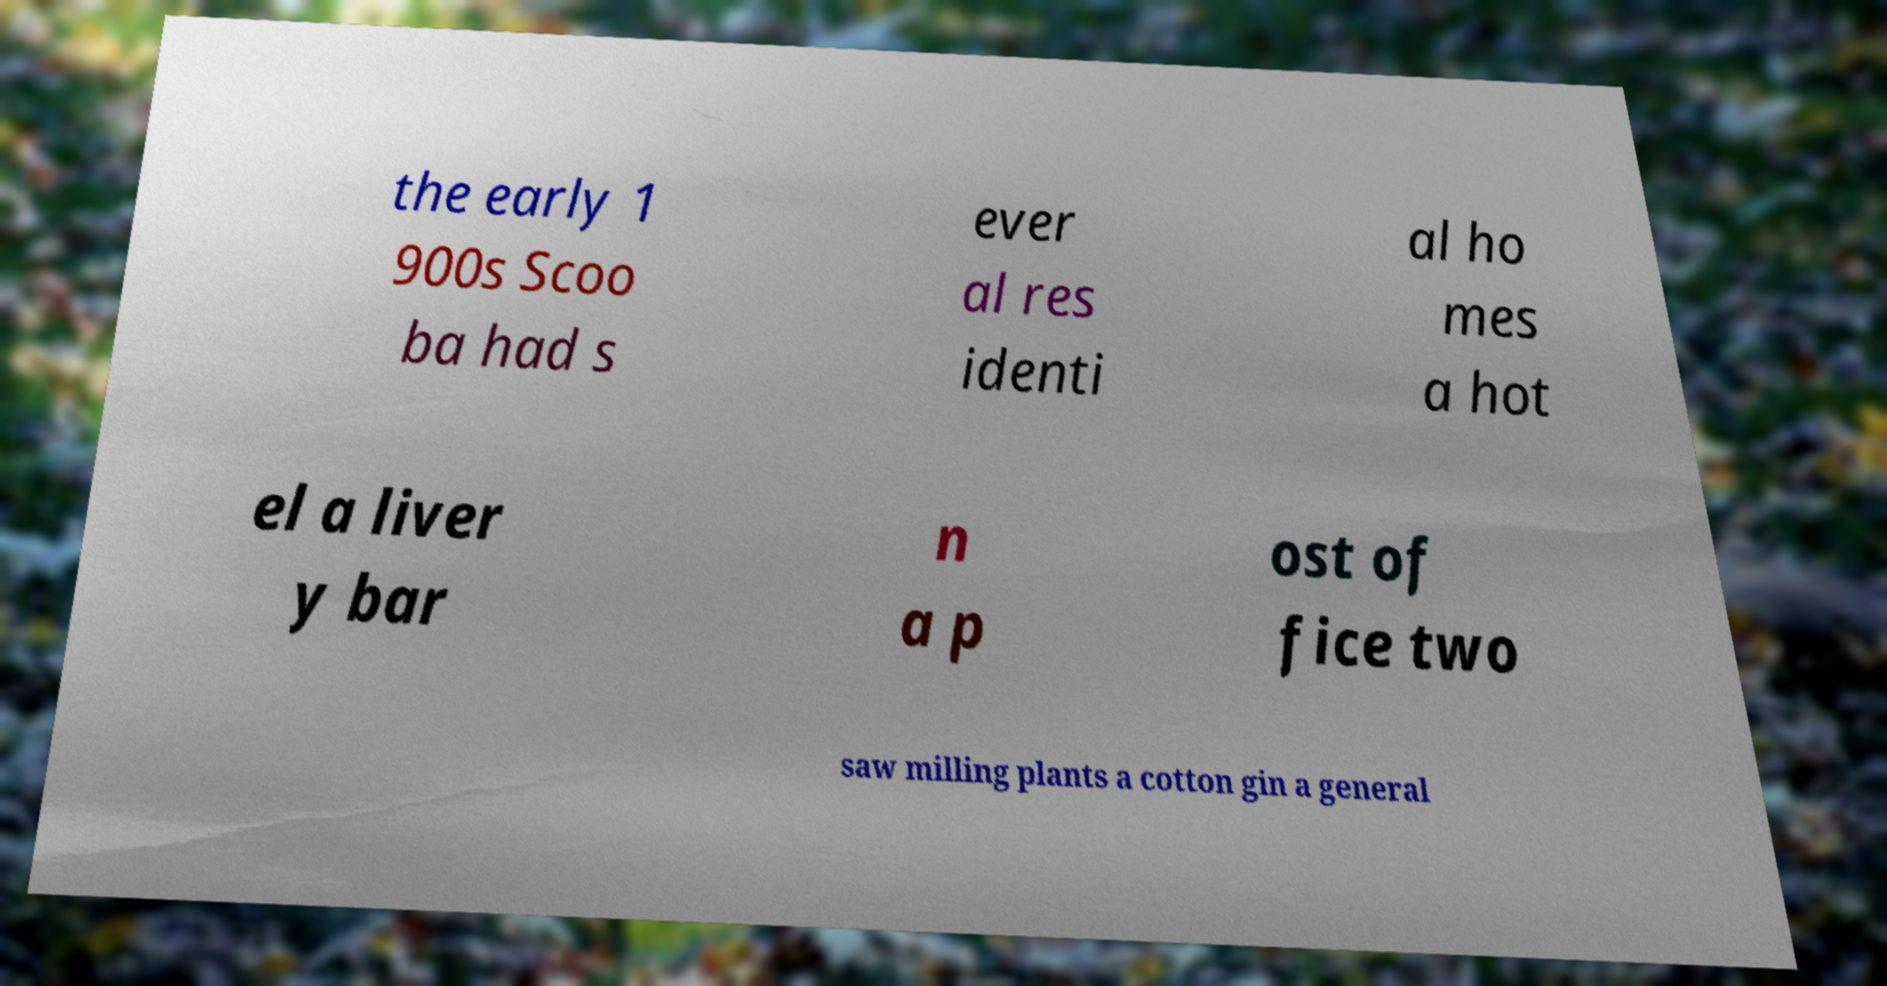What messages or text are displayed in this image? I need them in a readable, typed format. the early 1 900s Scoo ba had s ever al res identi al ho mes a hot el a liver y bar n a p ost of fice two saw milling plants a cotton gin a general 